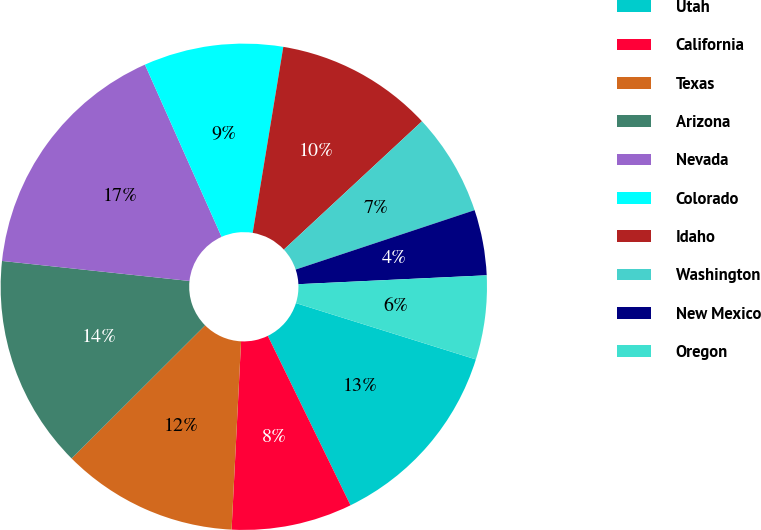Convert chart to OTSL. <chart><loc_0><loc_0><loc_500><loc_500><pie_chart><fcel>Utah<fcel>California<fcel>Texas<fcel>Arizona<fcel>Nevada<fcel>Colorado<fcel>Idaho<fcel>Washington<fcel>New Mexico<fcel>Oregon<nl><fcel>12.94%<fcel>8.03%<fcel>11.72%<fcel>14.17%<fcel>16.64%<fcel>9.26%<fcel>10.49%<fcel>6.81%<fcel>4.35%<fcel>5.58%<nl></chart> 